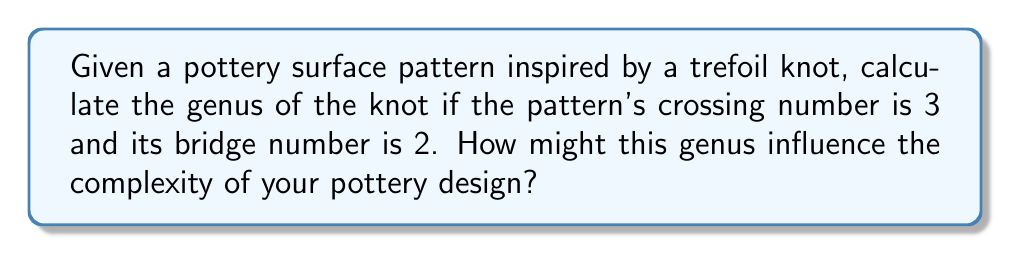Show me your answer to this math problem. To determine the genus of a knot based on a pottery surface pattern, we'll follow these steps:

1. Recall the relationship between genus (g), crossing number (c), and bridge number (b) for alternating knots:

   $$g \leq \frac{c - b + 1}{2}$$

2. In this case, we have:
   - Crossing number (c) = 3
   - Bridge number (b) = 2

3. Substitute these values into the formula:

   $$g \leq \frac{3 - 2 + 1}{2} = \frac{2}{2} = 1$$

4. Since the genus must be a non-negative integer, and the inequality gives us an upper bound of 1, we can conclude that the genus is exactly 1.

5. For a trefoil knot, which this pattern is based on, the genus is indeed 1, confirming our calculation.

The genus of a knot represents the minimum number of holes in a surface that the knot can bound without self-intersection. In pottery design, this could influence the complexity of your piece by suggesting the number of "handles" or "tunnels" you might incorporate into your design to reflect the knot's topology.
Answer: $g = 1$ 